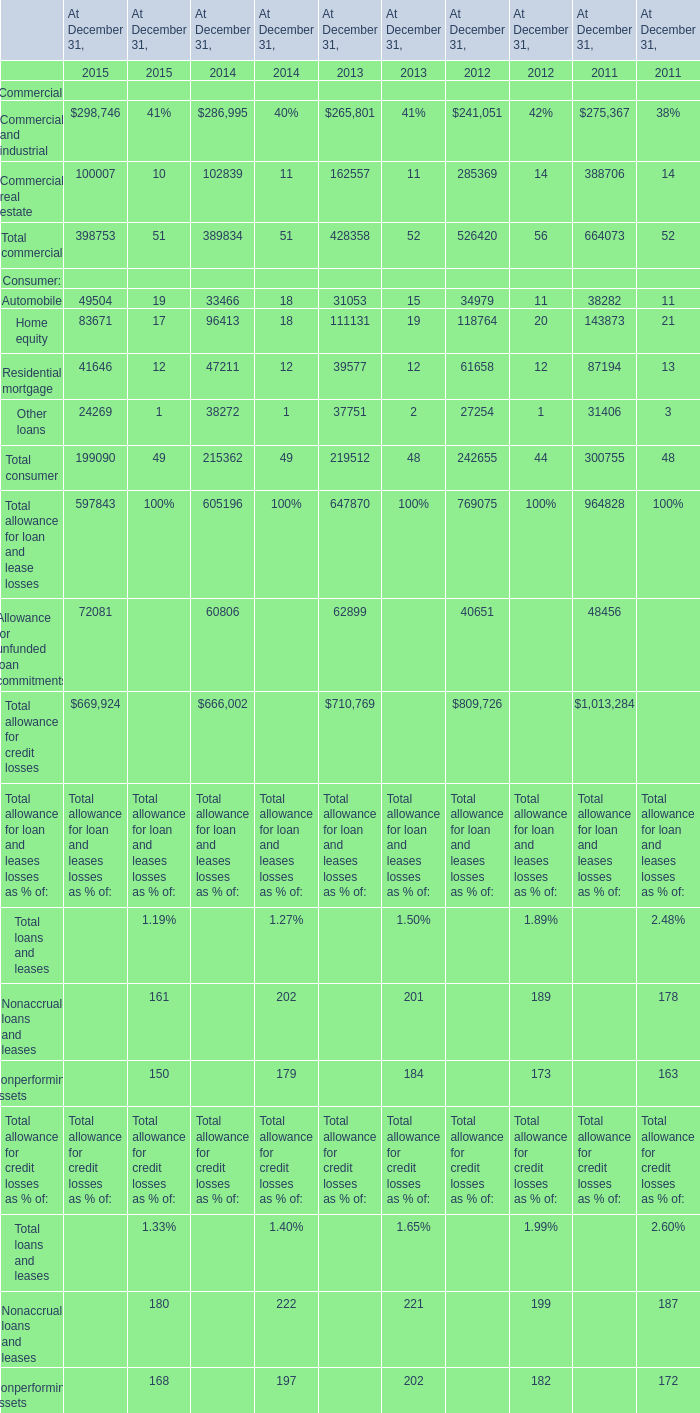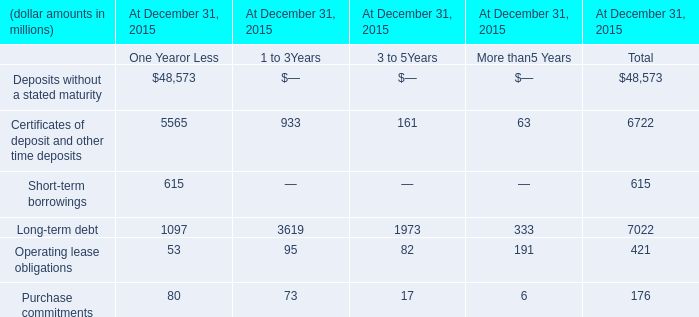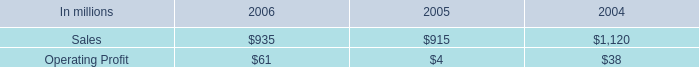What's the total amount of the Total consumer in the years where Commercial and industrial greater than 280000? 
Computations: (199090 + 215362)
Answer: 414452.0. 